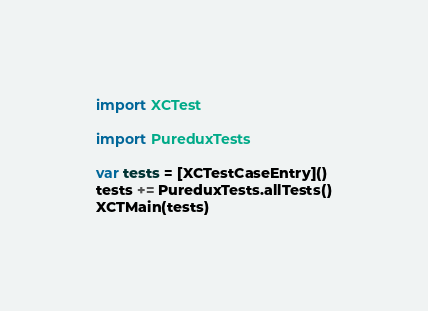Convert code to text. <code><loc_0><loc_0><loc_500><loc_500><_Swift_>import XCTest

import PureduxTests

var tests = [XCTestCaseEntry]()
tests += PureduxTests.allTests()
XCTMain(tests)
</code> 